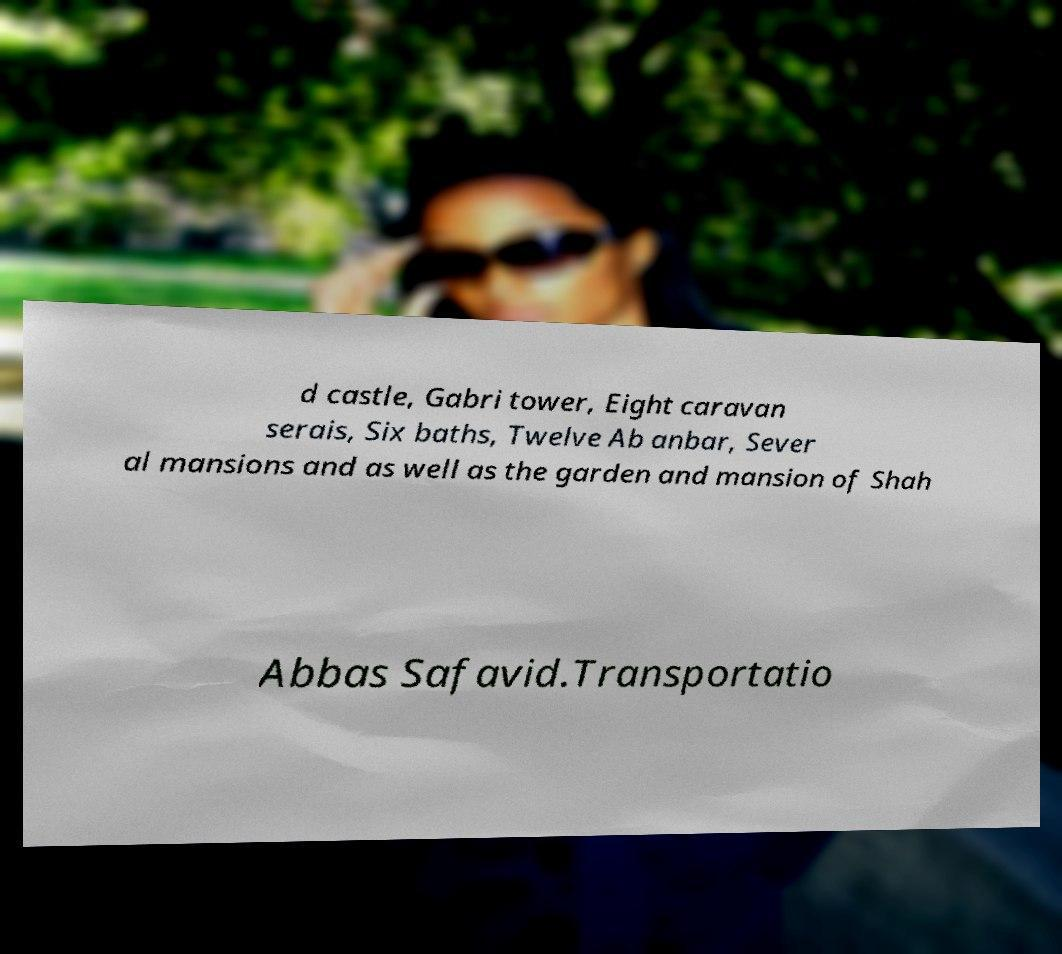There's text embedded in this image that I need extracted. Can you transcribe it verbatim? d castle, Gabri tower, Eight caravan serais, Six baths, Twelve Ab anbar, Sever al mansions and as well as the garden and mansion of Shah Abbas Safavid.Transportatio 